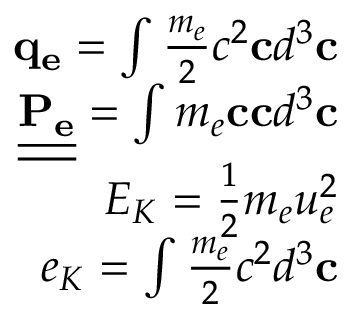<formula> <loc_0><loc_0><loc_500><loc_500>\begin{array} { r } { q _ { e } = \int \frac { m _ { e } } { 2 } c ^ { 2 } c d ^ { 3 } c } \\ { \underline { { \underline { { P _ { e } } } } } = \int m _ { e } c c d ^ { 3 } c } \\ { E _ { K } = \frac { 1 } { 2 } m _ { e } u _ { e } ^ { 2 } } \\ { e _ { K } = \int \frac { m _ { e } } { 2 } c ^ { 2 } d ^ { 3 } c } \end{array}</formula> 